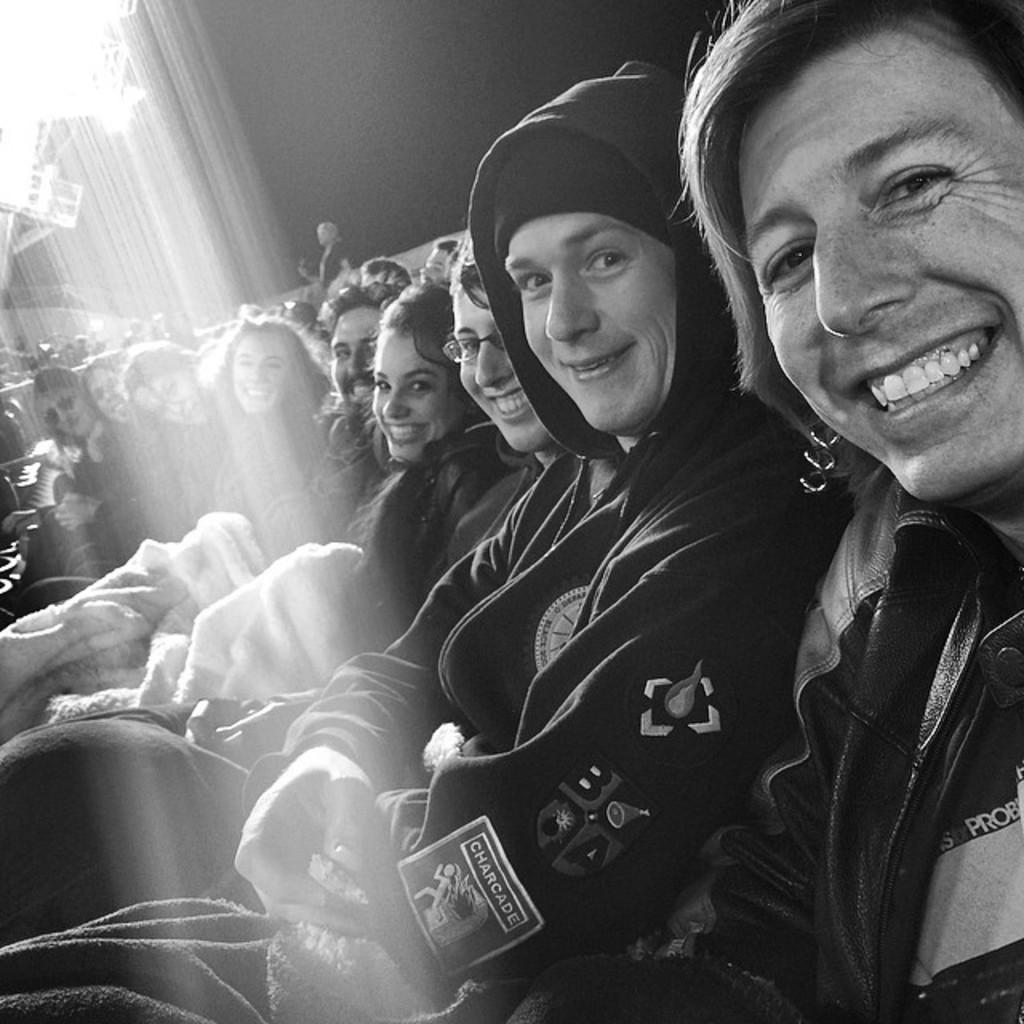What is the color scheme of the image? The image is black and white. What are the people in the image doing? There is a group of people sitting in the image. What can be seen in the background of the image? There is a wall and lights visible in the background of the image. Is there anyone else in the background besides the wall and lights? Yes, there is a person standing in the background of the image. What grade is the person standing in the background of the image teaching? There is no indication in the image that the person standing in the background is a teacher, nor is there any information about the grade they might be teaching. 